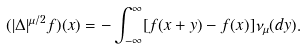Convert formula to latex. <formula><loc_0><loc_0><loc_500><loc_500>( | \Delta | ^ { \mu / 2 } f ) ( x ) = - \int _ { - \infty } ^ { \infty } [ f ( x + y ) - f ( x ) ] \nu _ { \mu } ( d y ) .</formula> 